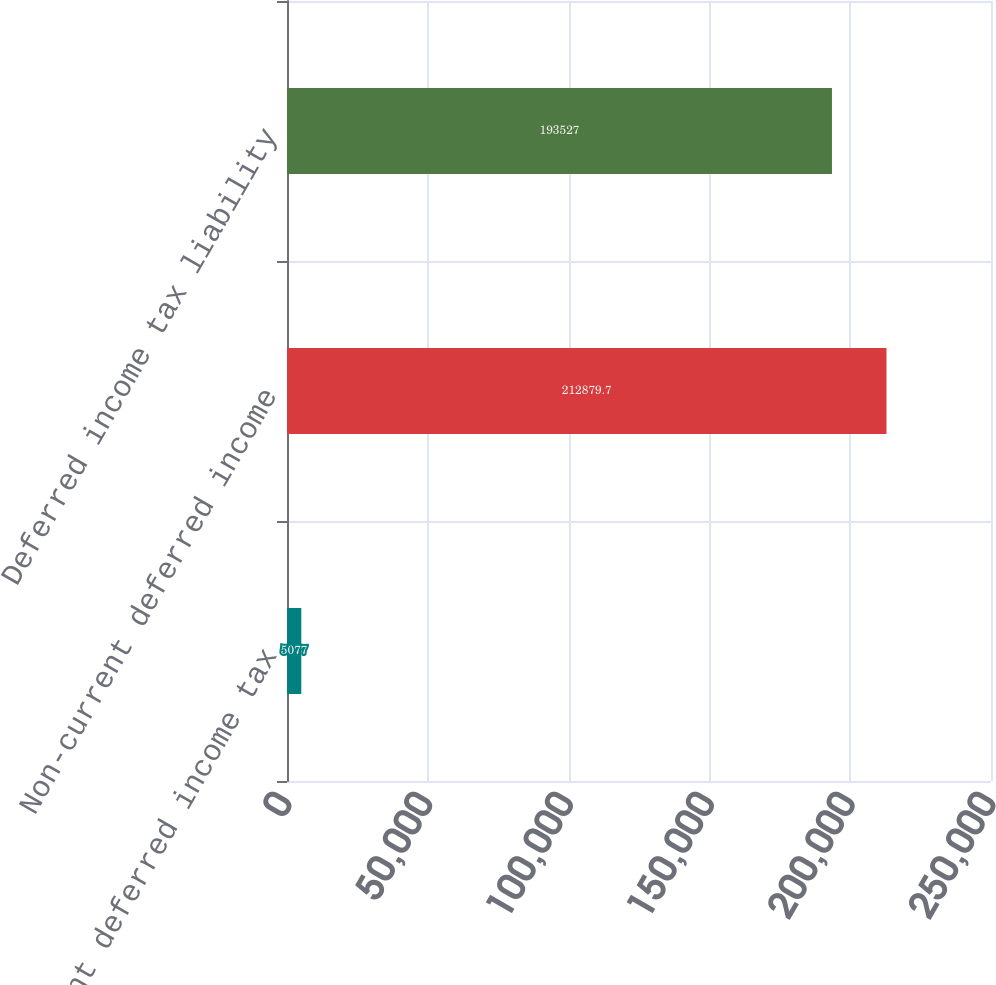<chart> <loc_0><loc_0><loc_500><loc_500><bar_chart><fcel>Current deferred income tax<fcel>Non-current deferred income<fcel>Deferred income tax liability<nl><fcel>5077<fcel>212880<fcel>193527<nl></chart> 